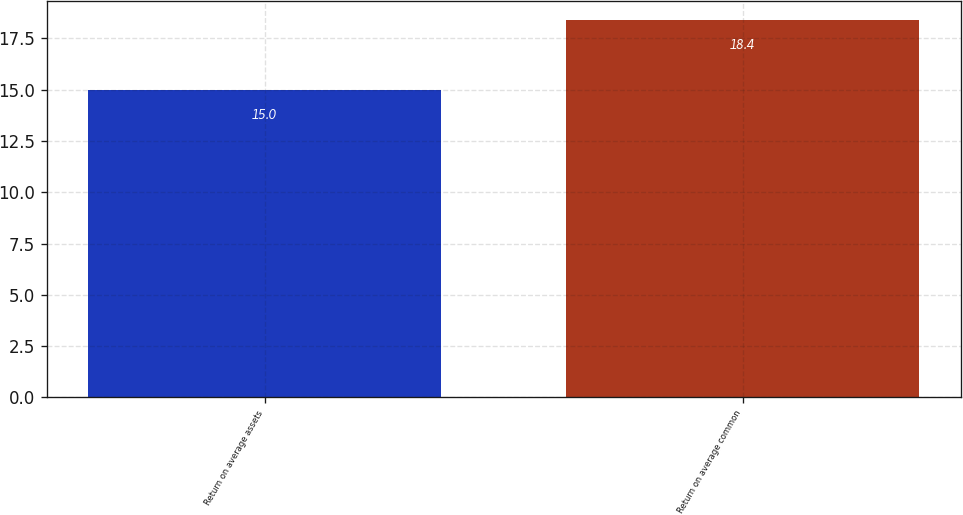Convert chart. <chart><loc_0><loc_0><loc_500><loc_500><bar_chart><fcel>Return on average assets<fcel>Return on average common<nl><fcel>15<fcel>18.4<nl></chart> 